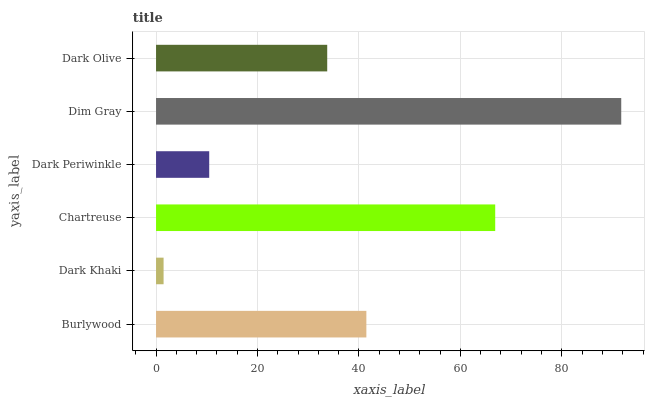Is Dark Khaki the minimum?
Answer yes or no. Yes. Is Dim Gray the maximum?
Answer yes or no. Yes. Is Chartreuse the minimum?
Answer yes or no. No. Is Chartreuse the maximum?
Answer yes or no. No. Is Chartreuse greater than Dark Khaki?
Answer yes or no. Yes. Is Dark Khaki less than Chartreuse?
Answer yes or no. Yes. Is Dark Khaki greater than Chartreuse?
Answer yes or no. No. Is Chartreuse less than Dark Khaki?
Answer yes or no. No. Is Burlywood the high median?
Answer yes or no. Yes. Is Dark Olive the low median?
Answer yes or no. Yes. Is Dark Olive the high median?
Answer yes or no. No. Is Dark Khaki the low median?
Answer yes or no. No. 